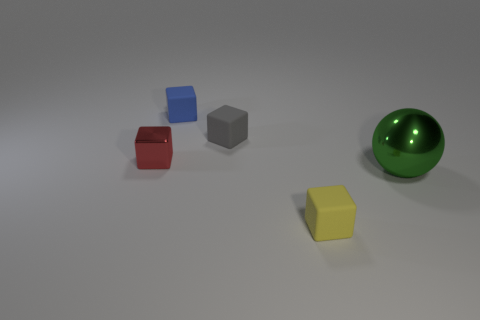Is the shape of the blue thing the same as the small gray matte thing?
Keep it short and to the point. Yes. There is a tiny matte cube that is in front of the object to the right of the small yellow rubber block; what is its color?
Give a very brief answer. Yellow. What material is the blue thing that is the same shape as the red thing?
Keep it short and to the point. Rubber. What number of metallic things are the same size as the yellow cube?
Keep it short and to the point. 1. There is a green ball that is made of the same material as the red cube; what is its size?
Ensure brevity in your answer.  Large. How many large green things are the same shape as the red metal thing?
Your answer should be very brief. 0. How many red cubes are there?
Offer a very short reply. 1. Does the rubber object that is in front of the green metal sphere have the same shape as the blue thing?
Your answer should be very brief. Yes. There is a red object that is the same size as the yellow rubber object; what is its material?
Your response must be concise. Metal. Is there a cyan cylinder made of the same material as the yellow object?
Give a very brief answer. No. 